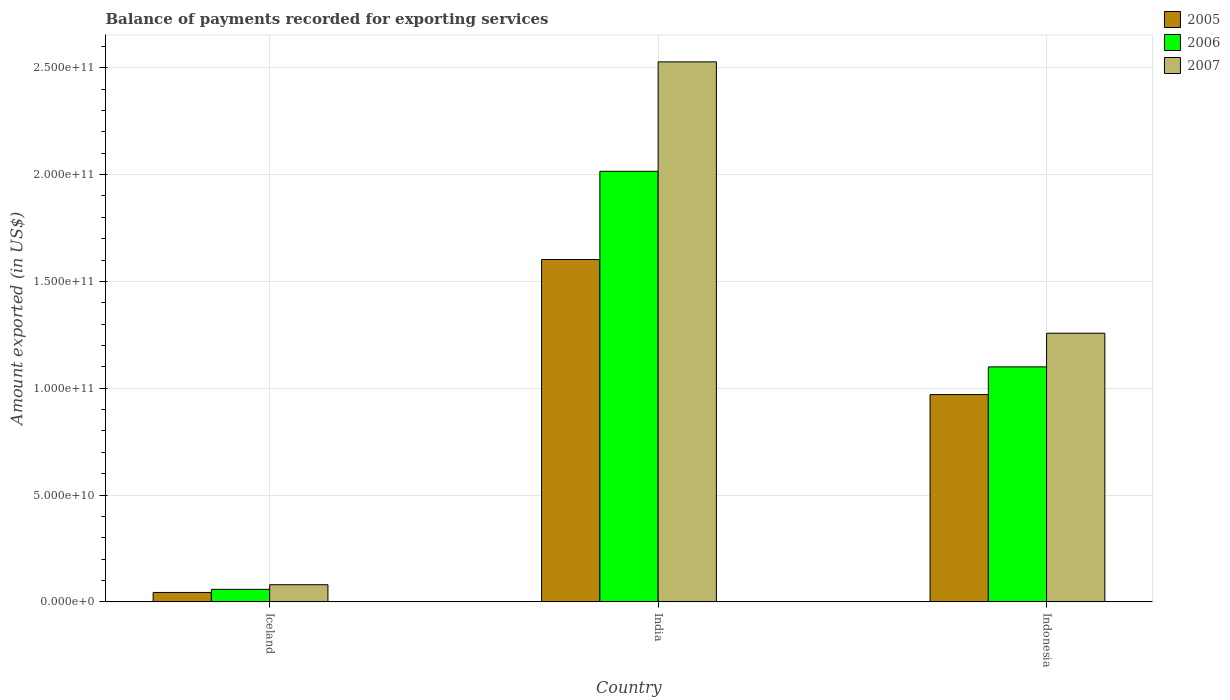How many groups of bars are there?
Make the answer very short. 3. Are the number of bars per tick equal to the number of legend labels?
Provide a succinct answer. Yes. Are the number of bars on each tick of the X-axis equal?
Your response must be concise. Yes. In how many cases, is the number of bars for a given country not equal to the number of legend labels?
Ensure brevity in your answer.  0. What is the amount exported in 2005 in India?
Your answer should be compact. 1.60e+11. Across all countries, what is the maximum amount exported in 2007?
Make the answer very short. 2.53e+11. Across all countries, what is the minimum amount exported in 2005?
Your answer should be compact. 4.42e+09. In which country was the amount exported in 2007 maximum?
Offer a terse response. India. What is the total amount exported in 2006 in the graph?
Ensure brevity in your answer.  3.17e+11. What is the difference between the amount exported in 2007 in Iceland and that in India?
Your answer should be compact. -2.45e+11. What is the difference between the amount exported in 2006 in India and the amount exported in 2005 in Indonesia?
Offer a terse response. 1.04e+11. What is the average amount exported in 2007 per country?
Give a very brief answer. 1.29e+11. What is the difference between the amount exported of/in 2005 and amount exported of/in 2006 in Indonesia?
Give a very brief answer. -1.30e+1. In how many countries, is the amount exported in 2007 greater than 200000000000 US$?
Your answer should be compact. 1. What is the ratio of the amount exported in 2007 in India to that in Indonesia?
Provide a short and direct response. 2.01. What is the difference between the highest and the second highest amount exported in 2005?
Give a very brief answer. -6.32e+1. What is the difference between the highest and the lowest amount exported in 2006?
Your answer should be very brief. 1.96e+11. In how many countries, is the amount exported in 2006 greater than the average amount exported in 2006 taken over all countries?
Make the answer very short. 2. What does the 2nd bar from the left in Indonesia represents?
Provide a short and direct response. 2006. Is it the case that in every country, the sum of the amount exported in 2005 and amount exported in 2006 is greater than the amount exported in 2007?
Offer a very short reply. Yes. Are the values on the major ticks of Y-axis written in scientific E-notation?
Your answer should be compact. Yes. Does the graph contain any zero values?
Ensure brevity in your answer.  No. Where does the legend appear in the graph?
Keep it short and to the point. Top right. How are the legend labels stacked?
Your answer should be very brief. Vertical. What is the title of the graph?
Give a very brief answer. Balance of payments recorded for exporting services. What is the label or title of the Y-axis?
Make the answer very short. Amount exported (in US$). What is the Amount exported (in US$) in 2005 in Iceland?
Ensure brevity in your answer.  4.42e+09. What is the Amount exported (in US$) in 2006 in Iceland?
Keep it short and to the point. 5.86e+09. What is the Amount exported (in US$) in 2007 in Iceland?
Provide a short and direct response. 8.03e+09. What is the Amount exported (in US$) in 2005 in India?
Ensure brevity in your answer.  1.60e+11. What is the Amount exported (in US$) in 2006 in India?
Ensure brevity in your answer.  2.02e+11. What is the Amount exported (in US$) in 2007 in India?
Ensure brevity in your answer.  2.53e+11. What is the Amount exported (in US$) in 2005 in Indonesia?
Give a very brief answer. 9.70e+1. What is the Amount exported (in US$) in 2006 in Indonesia?
Your response must be concise. 1.10e+11. What is the Amount exported (in US$) of 2007 in Indonesia?
Your answer should be very brief. 1.26e+11. Across all countries, what is the maximum Amount exported (in US$) in 2005?
Provide a succinct answer. 1.60e+11. Across all countries, what is the maximum Amount exported (in US$) of 2006?
Your answer should be very brief. 2.02e+11. Across all countries, what is the maximum Amount exported (in US$) of 2007?
Provide a short and direct response. 2.53e+11. Across all countries, what is the minimum Amount exported (in US$) in 2005?
Ensure brevity in your answer.  4.42e+09. Across all countries, what is the minimum Amount exported (in US$) in 2006?
Provide a short and direct response. 5.86e+09. Across all countries, what is the minimum Amount exported (in US$) of 2007?
Ensure brevity in your answer.  8.03e+09. What is the total Amount exported (in US$) of 2005 in the graph?
Provide a succinct answer. 2.62e+11. What is the total Amount exported (in US$) of 2006 in the graph?
Your answer should be very brief. 3.17e+11. What is the total Amount exported (in US$) in 2007 in the graph?
Provide a succinct answer. 3.86e+11. What is the difference between the Amount exported (in US$) in 2005 in Iceland and that in India?
Your response must be concise. -1.56e+11. What is the difference between the Amount exported (in US$) of 2006 in Iceland and that in India?
Ensure brevity in your answer.  -1.96e+11. What is the difference between the Amount exported (in US$) of 2007 in Iceland and that in India?
Your answer should be compact. -2.45e+11. What is the difference between the Amount exported (in US$) in 2005 in Iceland and that in Indonesia?
Offer a very short reply. -9.26e+1. What is the difference between the Amount exported (in US$) of 2006 in Iceland and that in Indonesia?
Give a very brief answer. -1.04e+11. What is the difference between the Amount exported (in US$) of 2007 in Iceland and that in Indonesia?
Give a very brief answer. -1.18e+11. What is the difference between the Amount exported (in US$) of 2005 in India and that in Indonesia?
Offer a very short reply. 6.32e+1. What is the difference between the Amount exported (in US$) in 2006 in India and that in Indonesia?
Your answer should be compact. 9.15e+1. What is the difference between the Amount exported (in US$) of 2007 in India and that in Indonesia?
Provide a succinct answer. 1.27e+11. What is the difference between the Amount exported (in US$) in 2005 in Iceland and the Amount exported (in US$) in 2006 in India?
Give a very brief answer. -1.97e+11. What is the difference between the Amount exported (in US$) in 2005 in Iceland and the Amount exported (in US$) in 2007 in India?
Provide a succinct answer. -2.48e+11. What is the difference between the Amount exported (in US$) in 2006 in Iceland and the Amount exported (in US$) in 2007 in India?
Provide a succinct answer. -2.47e+11. What is the difference between the Amount exported (in US$) of 2005 in Iceland and the Amount exported (in US$) of 2006 in Indonesia?
Your answer should be very brief. -1.06e+11. What is the difference between the Amount exported (in US$) of 2005 in Iceland and the Amount exported (in US$) of 2007 in Indonesia?
Give a very brief answer. -1.21e+11. What is the difference between the Amount exported (in US$) in 2006 in Iceland and the Amount exported (in US$) in 2007 in Indonesia?
Make the answer very short. -1.20e+11. What is the difference between the Amount exported (in US$) of 2005 in India and the Amount exported (in US$) of 2006 in Indonesia?
Keep it short and to the point. 5.02e+1. What is the difference between the Amount exported (in US$) in 2005 in India and the Amount exported (in US$) in 2007 in Indonesia?
Offer a very short reply. 3.45e+1. What is the difference between the Amount exported (in US$) of 2006 in India and the Amount exported (in US$) of 2007 in Indonesia?
Your answer should be compact. 7.58e+1. What is the average Amount exported (in US$) in 2005 per country?
Make the answer very short. 8.72e+1. What is the average Amount exported (in US$) of 2006 per country?
Offer a terse response. 1.06e+11. What is the average Amount exported (in US$) in 2007 per country?
Your answer should be compact. 1.29e+11. What is the difference between the Amount exported (in US$) in 2005 and Amount exported (in US$) in 2006 in Iceland?
Keep it short and to the point. -1.44e+09. What is the difference between the Amount exported (in US$) in 2005 and Amount exported (in US$) in 2007 in Iceland?
Your answer should be very brief. -3.61e+09. What is the difference between the Amount exported (in US$) of 2006 and Amount exported (in US$) of 2007 in Iceland?
Offer a terse response. -2.17e+09. What is the difference between the Amount exported (in US$) in 2005 and Amount exported (in US$) in 2006 in India?
Provide a succinct answer. -4.13e+1. What is the difference between the Amount exported (in US$) of 2005 and Amount exported (in US$) of 2007 in India?
Make the answer very short. -9.25e+1. What is the difference between the Amount exported (in US$) of 2006 and Amount exported (in US$) of 2007 in India?
Offer a very short reply. -5.12e+1. What is the difference between the Amount exported (in US$) in 2005 and Amount exported (in US$) in 2006 in Indonesia?
Your answer should be compact. -1.30e+1. What is the difference between the Amount exported (in US$) of 2005 and Amount exported (in US$) of 2007 in Indonesia?
Provide a succinct answer. -2.87e+1. What is the difference between the Amount exported (in US$) of 2006 and Amount exported (in US$) of 2007 in Indonesia?
Keep it short and to the point. -1.57e+1. What is the ratio of the Amount exported (in US$) in 2005 in Iceland to that in India?
Provide a short and direct response. 0.03. What is the ratio of the Amount exported (in US$) of 2006 in Iceland to that in India?
Your answer should be very brief. 0.03. What is the ratio of the Amount exported (in US$) of 2007 in Iceland to that in India?
Offer a very short reply. 0.03. What is the ratio of the Amount exported (in US$) of 2005 in Iceland to that in Indonesia?
Your answer should be compact. 0.05. What is the ratio of the Amount exported (in US$) in 2006 in Iceland to that in Indonesia?
Your answer should be very brief. 0.05. What is the ratio of the Amount exported (in US$) of 2007 in Iceland to that in Indonesia?
Ensure brevity in your answer.  0.06. What is the ratio of the Amount exported (in US$) in 2005 in India to that in Indonesia?
Offer a terse response. 1.65. What is the ratio of the Amount exported (in US$) of 2006 in India to that in Indonesia?
Ensure brevity in your answer.  1.83. What is the ratio of the Amount exported (in US$) of 2007 in India to that in Indonesia?
Provide a succinct answer. 2.01. What is the difference between the highest and the second highest Amount exported (in US$) in 2005?
Ensure brevity in your answer.  6.32e+1. What is the difference between the highest and the second highest Amount exported (in US$) of 2006?
Ensure brevity in your answer.  9.15e+1. What is the difference between the highest and the second highest Amount exported (in US$) in 2007?
Keep it short and to the point. 1.27e+11. What is the difference between the highest and the lowest Amount exported (in US$) in 2005?
Keep it short and to the point. 1.56e+11. What is the difference between the highest and the lowest Amount exported (in US$) in 2006?
Your response must be concise. 1.96e+11. What is the difference between the highest and the lowest Amount exported (in US$) in 2007?
Provide a succinct answer. 2.45e+11. 